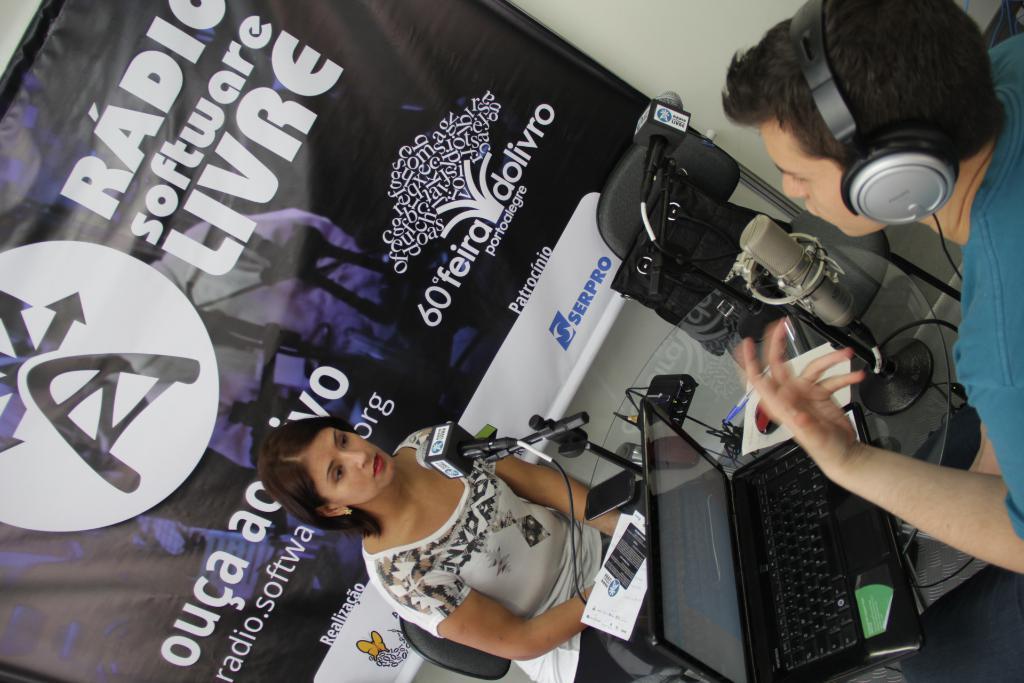What is the brand being promoted?
Your answer should be compact. Serpro. 